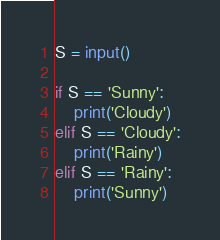<code> <loc_0><loc_0><loc_500><loc_500><_Python_>S = input()

if S == 'Sunny':
    print('Cloudy')
elif S == 'Cloudy':
    print('Rainy')
elif S == 'Rainy':
    print('Sunny')</code> 